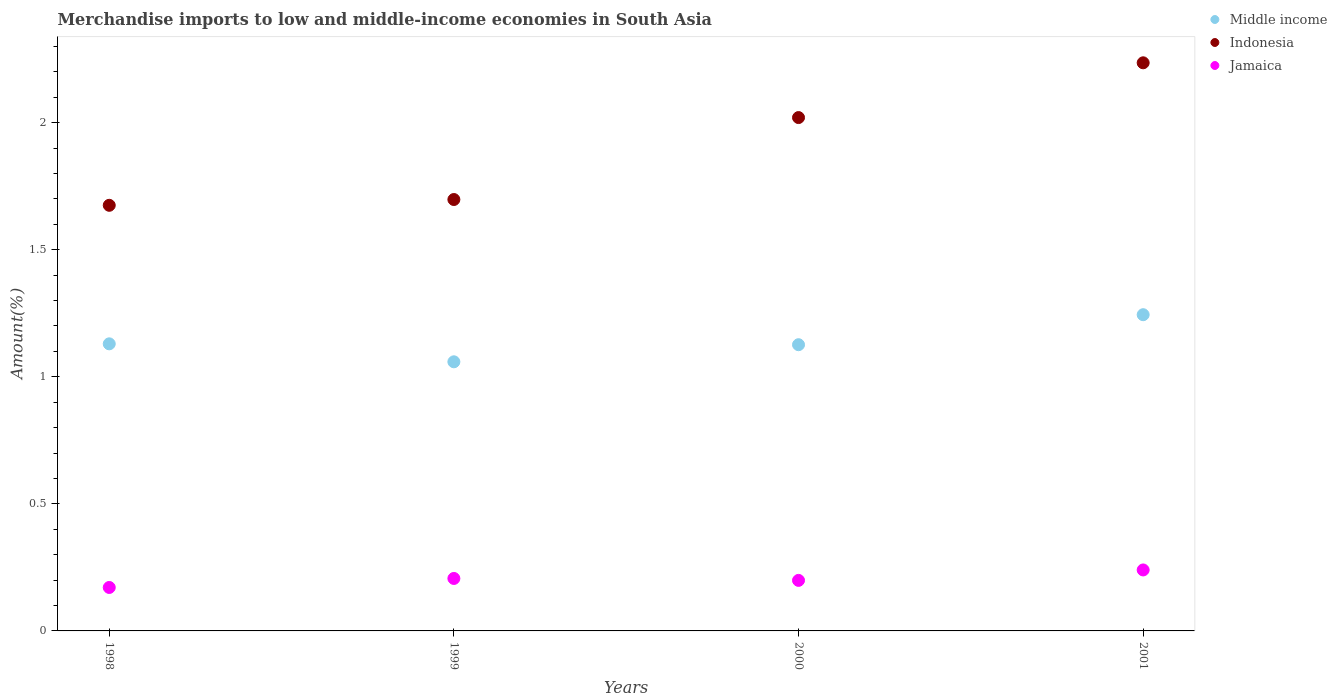What is the percentage of amount earned from merchandise imports in Jamaica in 2001?
Offer a terse response. 0.24. Across all years, what is the maximum percentage of amount earned from merchandise imports in Middle income?
Your answer should be compact. 1.24. Across all years, what is the minimum percentage of amount earned from merchandise imports in Middle income?
Your response must be concise. 1.06. In which year was the percentage of amount earned from merchandise imports in Middle income minimum?
Your answer should be very brief. 1999. What is the total percentage of amount earned from merchandise imports in Middle income in the graph?
Provide a succinct answer. 4.56. What is the difference between the percentage of amount earned from merchandise imports in Jamaica in 1999 and that in 2001?
Provide a succinct answer. -0.03. What is the difference between the percentage of amount earned from merchandise imports in Middle income in 1998 and the percentage of amount earned from merchandise imports in Indonesia in 2001?
Offer a terse response. -1.11. What is the average percentage of amount earned from merchandise imports in Jamaica per year?
Your answer should be very brief. 0.2. In the year 2000, what is the difference between the percentage of amount earned from merchandise imports in Middle income and percentage of amount earned from merchandise imports in Indonesia?
Make the answer very short. -0.89. What is the ratio of the percentage of amount earned from merchandise imports in Indonesia in 1999 to that in 2000?
Provide a succinct answer. 0.84. Is the percentage of amount earned from merchandise imports in Middle income in 1998 less than that in 2001?
Provide a short and direct response. Yes. Is the difference between the percentage of amount earned from merchandise imports in Middle income in 1998 and 2000 greater than the difference between the percentage of amount earned from merchandise imports in Indonesia in 1998 and 2000?
Your answer should be compact. Yes. What is the difference between the highest and the second highest percentage of amount earned from merchandise imports in Indonesia?
Your response must be concise. 0.22. What is the difference between the highest and the lowest percentage of amount earned from merchandise imports in Middle income?
Provide a succinct answer. 0.19. Is the sum of the percentage of amount earned from merchandise imports in Jamaica in 2000 and 2001 greater than the maximum percentage of amount earned from merchandise imports in Middle income across all years?
Keep it short and to the point. No. Is the percentage of amount earned from merchandise imports in Indonesia strictly less than the percentage of amount earned from merchandise imports in Jamaica over the years?
Make the answer very short. No. How many dotlines are there?
Offer a very short reply. 3. How many years are there in the graph?
Make the answer very short. 4. Where does the legend appear in the graph?
Provide a short and direct response. Top right. How many legend labels are there?
Your answer should be compact. 3. How are the legend labels stacked?
Provide a short and direct response. Vertical. What is the title of the graph?
Ensure brevity in your answer.  Merchandise imports to low and middle-income economies in South Asia. Does "Gabon" appear as one of the legend labels in the graph?
Keep it short and to the point. No. What is the label or title of the X-axis?
Keep it short and to the point. Years. What is the label or title of the Y-axis?
Offer a terse response. Amount(%). What is the Amount(%) in Middle income in 1998?
Give a very brief answer. 1.13. What is the Amount(%) in Indonesia in 1998?
Offer a very short reply. 1.67. What is the Amount(%) in Jamaica in 1998?
Provide a succinct answer. 0.17. What is the Amount(%) of Middle income in 1999?
Offer a terse response. 1.06. What is the Amount(%) in Indonesia in 1999?
Offer a terse response. 1.7. What is the Amount(%) of Jamaica in 1999?
Give a very brief answer. 0.21. What is the Amount(%) in Middle income in 2000?
Ensure brevity in your answer.  1.13. What is the Amount(%) in Indonesia in 2000?
Keep it short and to the point. 2.02. What is the Amount(%) in Jamaica in 2000?
Provide a short and direct response. 0.2. What is the Amount(%) of Middle income in 2001?
Your answer should be very brief. 1.24. What is the Amount(%) of Indonesia in 2001?
Your answer should be very brief. 2.24. What is the Amount(%) in Jamaica in 2001?
Offer a terse response. 0.24. Across all years, what is the maximum Amount(%) in Middle income?
Offer a terse response. 1.24. Across all years, what is the maximum Amount(%) in Indonesia?
Provide a short and direct response. 2.24. Across all years, what is the maximum Amount(%) of Jamaica?
Keep it short and to the point. 0.24. Across all years, what is the minimum Amount(%) of Middle income?
Make the answer very short. 1.06. Across all years, what is the minimum Amount(%) of Indonesia?
Offer a very short reply. 1.67. Across all years, what is the minimum Amount(%) in Jamaica?
Your answer should be very brief. 0.17. What is the total Amount(%) in Middle income in the graph?
Your answer should be compact. 4.56. What is the total Amount(%) in Indonesia in the graph?
Make the answer very short. 7.63. What is the total Amount(%) of Jamaica in the graph?
Offer a very short reply. 0.82. What is the difference between the Amount(%) in Middle income in 1998 and that in 1999?
Your answer should be very brief. 0.07. What is the difference between the Amount(%) in Indonesia in 1998 and that in 1999?
Provide a short and direct response. -0.02. What is the difference between the Amount(%) of Jamaica in 1998 and that in 1999?
Provide a succinct answer. -0.04. What is the difference between the Amount(%) of Middle income in 1998 and that in 2000?
Give a very brief answer. 0. What is the difference between the Amount(%) in Indonesia in 1998 and that in 2000?
Offer a terse response. -0.35. What is the difference between the Amount(%) in Jamaica in 1998 and that in 2000?
Offer a very short reply. -0.03. What is the difference between the Amount(%) in Middle income in 1998 and that in 2001?
Give a very brief answer. -0.11. What is the difference between the Amount(%) of Indonesia in 1998 and that in 2001?
Your answer should be compact. -0.56. What is the difference between the Amount(%) in Jamaica in 1998 and that in 2001?
Make the answer very short. -0.07. What is the difference between the Amount(%) in Middle income in 1999 and that in 2000?
Give a very brief answer. -0.07. What is the difference between the Amount(%) of Indonesia in 1999 and that in 2000?
Keep it short and to the point. -0.32. What is the difference between the Amount(%) of Jamaica in 1999 and that in 2000?
Offer a very short reply. 0.01. What is the difference between the Amount(%) of Middle income in 1999 and that in 2001?
Make the answer very short. -0.19. What is the difference between the Amount(%) in Indonesia in 1999 and that in 2001?
Keep it short and to the point. -0.54. What is the difference between the Amount(%) of Jamaica in 1999 and that in 2001?
Your answer should be very brief. -0.03. What is the difference between the Amount(%) in Middle income in 2000 and that in 2001?
Provide a short and direct response. -0.12. What is the difference between the Amount(%) in Indonesia in 2000 and that in 2001?
Provide a succinct answer. -0.22. What is the difference between the Amount(%) of Jamaica in 2000 and that in 2001?
Your response must be concise. -0.04. What is the difference between the Amount(%) of Middle income in 1998 and the Amount(%) of Indonesia in 1999?
Ensure brevity in your answer.  -0.57. What is the difference between the Amount(%) of Middle income in 1998 and the Amount(%) of Jamaica in 1999?
Keep it short and to the point. 0.92. What is the difference between the Amount(%) of Indonesia in 1998 and the Amount(%) of Jamaica in 1999?
Make the answer very short. 1.47. What is the difference between the Amount(%) of Middle income in 1998 and the Amount(%) of Indonesia in 2000?
Provide a succinct answer. -0.89. What is the difference between the Amount(%) of Middle income in 1998 and the Amount(%) of Jamaica in 2000?
Make the answer very short. 0.93. What is the difference between the Amount(%) of Indonesia in 1998 and the Amount(%) of Jamaica in 2000?
Provide a succinct answer. 1.48. What is the difference between the Amount(%) in Middle income in 1998 and the Amount(%) in Indonesia in 2001?
Your answer should be compact. -1.11. What is the difference between the Amount(%) in Middle income in 1998 and the Amount(%) in Jamaica in 2001?
Offer a very short reply. 0.89. What is the difference between the Amount(%) of Indonesia in 1998 and the Amount(%) of Jamaica in 2001?
Your response must be concise. 1.44. What is the difference between the Amount(%) of Middle income in 1999 and the Amount(%) of Indonesia in 2000?
Give a very brief answer. -0.96. What is the difference between the Amount(%) in Middle income in 1999 and the Amount(%) in Jamaica in 2000?
Provide a succinct answer. 0.86. What is the difference between the Amount(%) in Indonesia in 1999 and the Amount(%) in Jamaica in 2000?
Offer a very short reply. 1.5. What is the difference between the Amount(%) in Middle income in 1999 and the Amount(%) in Indonesia in 2001?
Offer a very short reply. -1.18. What is the difference between the Amount(%) of Middle income in 1999 and the Amount(%) of Jamaica in 2001?
Provide a succinct answer. 0.82. What is the difference between the Amount(%) in Indonesia in 1999 and the Amount(%) in Jamaica in 2001?
Offer a terse response. 1.46. What is the difference between the Amount(%) of Middle income in 2000 and the Amount(%) of Indonesia in 2001?
Your response must be concise. -1.11. What is the difference between the Amount(%) in Middle income in 2000 and the Amount(%) in Jamaica in 2001?
Provide a succinct answer. 0.89. What is the difference between the Amount(%) in Indonesia in 2000 and the Amount(%) in Jamaica in 2001?
Keep it short and to the point. 1.78. What is the average Amount(%) in Middle income per year?
Give a very brief answer. 1.14. What is the average Amount(%) in Indonesia per year?
Provide a short and direct response. 1.91. What is the average Amount(%) of Jamaica per year?
Keep it short and to the point. 0.2. In the year 1998, what is the difference between the Amount(%) in Middle income and Amount(%) in Indonesia?
Provide a short and direct response. -0.55. In the year 1998, what is the difference between the Amount(%) in Middle income and Amount(%) in Jamaica?
Your response must be concise. 0.96. In the year 1998, what is the difference between the Amount(%) of Indonesia and Amount(%) of Jamaica?
Offer a terse response. 1.5. In the year 1999, what is the difference between the Amount(%) in Middle income and Amount(%) in Indonesia?
Give a very brief answer. -0.64. In the year 1999, what is the difference between the Amount(%) in Middle income and Amount(%) in Jamaica?
Your answer should be compact. 0.85. In the year 1999, what is the difference between the Amount(%) of Indonesia and Amount(%) of Jamaica?
Give a very brief answer. 1.49. In the year 2000, what is the difference between the Amount(%) of Middle income and Amount(%) of Indonesia?
Make the answer very short. -0.89. In the year 2000, what is the difference between the Amount(%) of Middle income and Amount(%) of Jamaica?
Your response must be concise. 0.93. In the year 2000, what is the difference between the Amount(%) of Indonesia and Amount(%) of Jamaica?
Keep it short and to the point. 1.82. In the year 2001, what is the difference between the Amount(%) of Middle income and Amount(%) of Indonesia?
Provide a short and direct response. -0.99. In the year 2001, what is the difference between the Amount(%) in Indonesia and Amount(%) in Jamaica?
Provide a succinct answer. 2. What is the ratio of the Amount(%) of Middle income in 1998 to that in 1999?
Give a very brief answer. 1.07. What is the ratio of the Amount(%) in Indonesia in 1998 to that in 1999?
Offer a very short reply. 0.99. What is the ratio of the Amount(%) of Jamaica in 1998 to that in 1999?
Your answer should be compact. 0.83. What is the ratio of the Amount(%) in Middle income in 1998 to that in 2000?
Give a very brief answer. 1. What is the ratio of the Amount(%) of Indonesia in 1998 to that in 2000?
Offer a very short reply. 0.83. What is the ratio of the Amount(%) of Jamaica in 1998 to that in 2000?
Ensure brevity in your answer.  0.86. What is the ratio of the Amount(%) of Middle income in 1998 to that in 2001?
Ensure brevity in your answer.  0.91. What is the ratio of the Amount(%) in Indonesia in 1998 to that in 2001?
Your answer should be very brief. 0.75. What is the ratio of the Amount(%) in Jamaica in 1998 to that in 2001?
Offer a terse response. 0.71. What is the ratio of the Amount(%) of Middle income in 1999 to that in 2000?
Keep it short and to the point. 0.94. What is the ratio of the Amount(%) in Indonesia in 1999 to that in 2000?
Your answer should be compact. 0.84. What is the ratio of the Amount(%) in Jamaica in 1999 to that in 2000?
Ensure brevity in your answer.  1.04. What is the ratio of the Amount(%) in Middle income in 1999 to that in 2001?
Keep it short and to the point. 0.85. What is the ratio of the Amount(%) of Indonesia in 1999 to that in 2001?
Keep it short and to the point. 0.76. What is the ratio of the Amount(%) of Jamaica in 1999 to that in 2001?
Ensure brevity in your answer.  0.86. What is the ratio of the Amount(%) in Middle income in 2000 to that in 2001?
Your response must be concise. 0.91. What is the ratio of the Amount(%) of Indonesia in 2000 to that in 2001?
Provide a succinct answer. 0.9. What is the ratio of the Amount(%) of Jamaica in 2000 to that in 2001?
Provide a short and direct response. 0.83. What is the difference between the highest and the second highest Amount(%) in Middle income?
Keep it short and to the point. 0.11. What is the difference between the highest and the second highest Amount(%) in Indonesia?
Ensure brevity in your answer.  0.22. What is the difference between the highest and the second highest Amount(%) of Jamaica?
Provide a succinct answer. 0.03. What is the difference between the highest and the lowest Amount(%) in Middle income?
Make the answer very short. 0.19. What is the difference between the highest and the lowest Amount(%) of Indonesia?
Ensure brevity in your answer.  0.56. What is the difference between the highest and the lowest Amount(%) of Jamaica?
Keep it short and to the point. 0.07. 